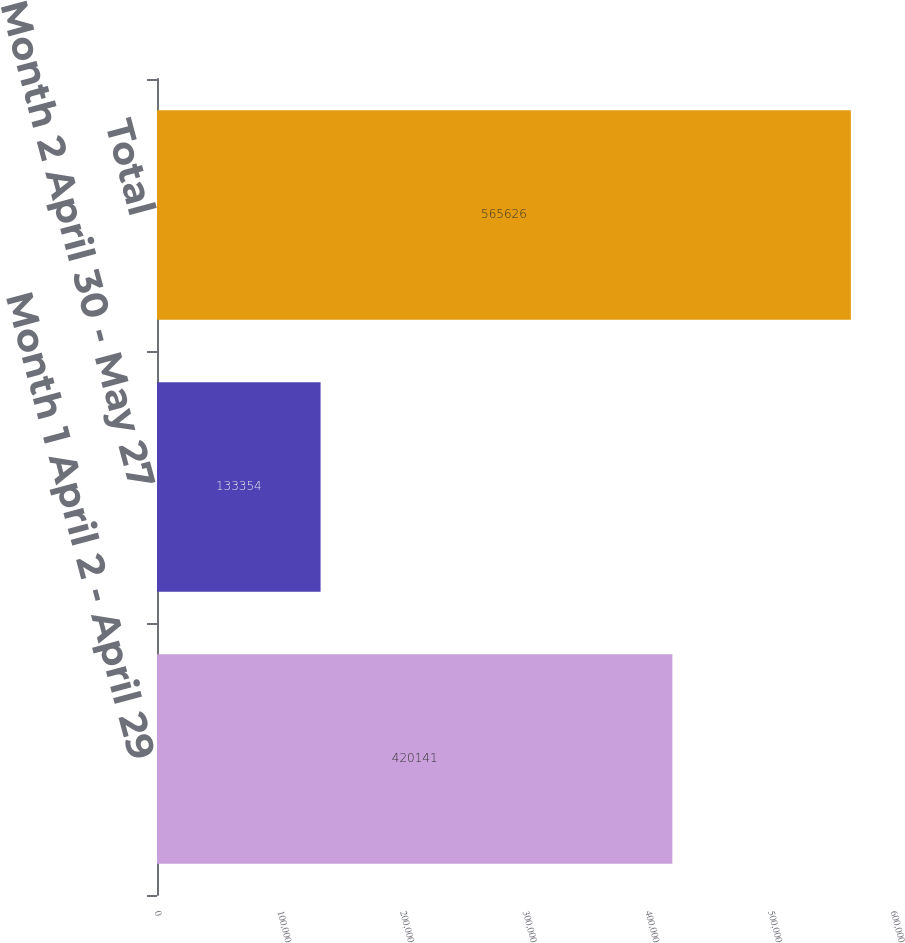Convert chart to OTSL. <chart><loc_0><loc_0><loc_500><loc_500><bar_chart><fcel>Month 1 April 2 - April 29<fcel>Month 2 April 30 - May 27<fcel>Total<nl><fcel>420141<fcel>133354<fcel>565626<nl></chart> 